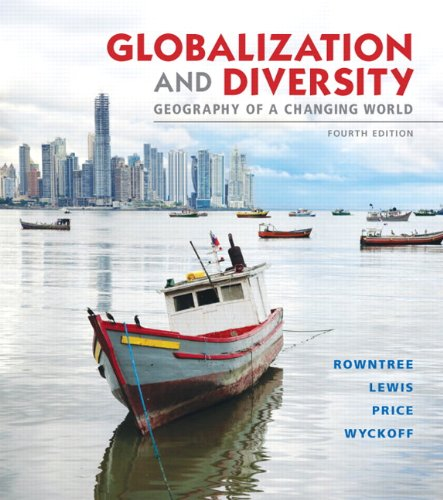Is this a fitness book? No, this book is not related to fitness; it is an academic text focused on the subjects of geography and the varied effects of globalization. 